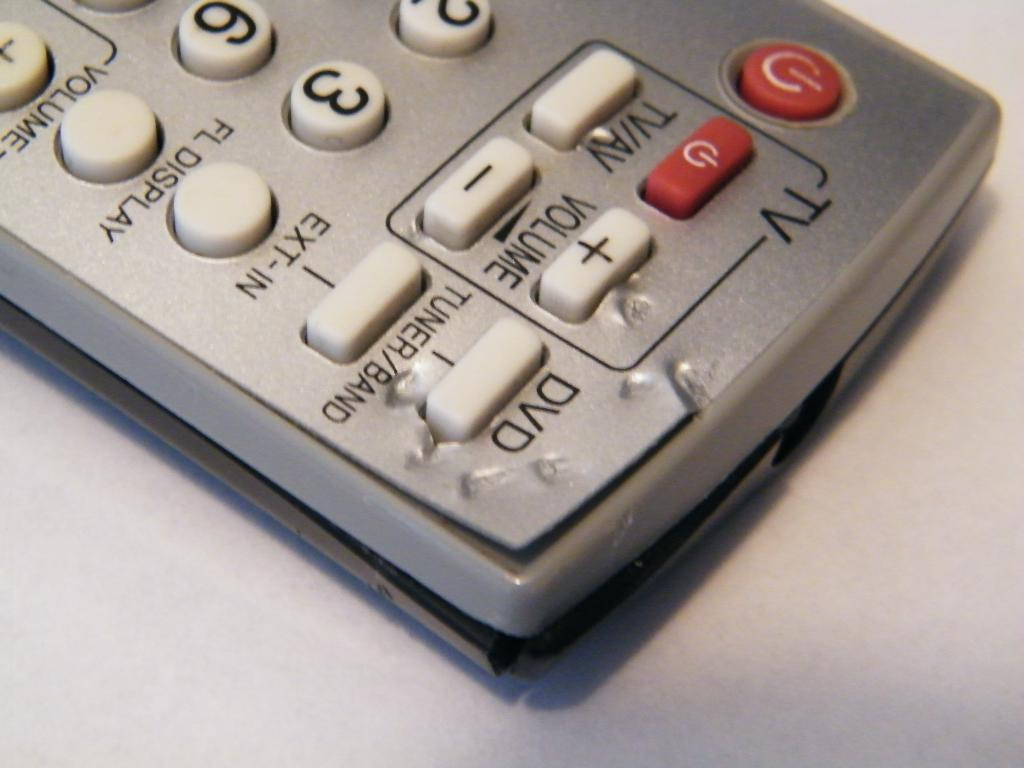<image>
Provide a brief description of the given image. A silver remote with red and white buttons that controls either a TV or VD 